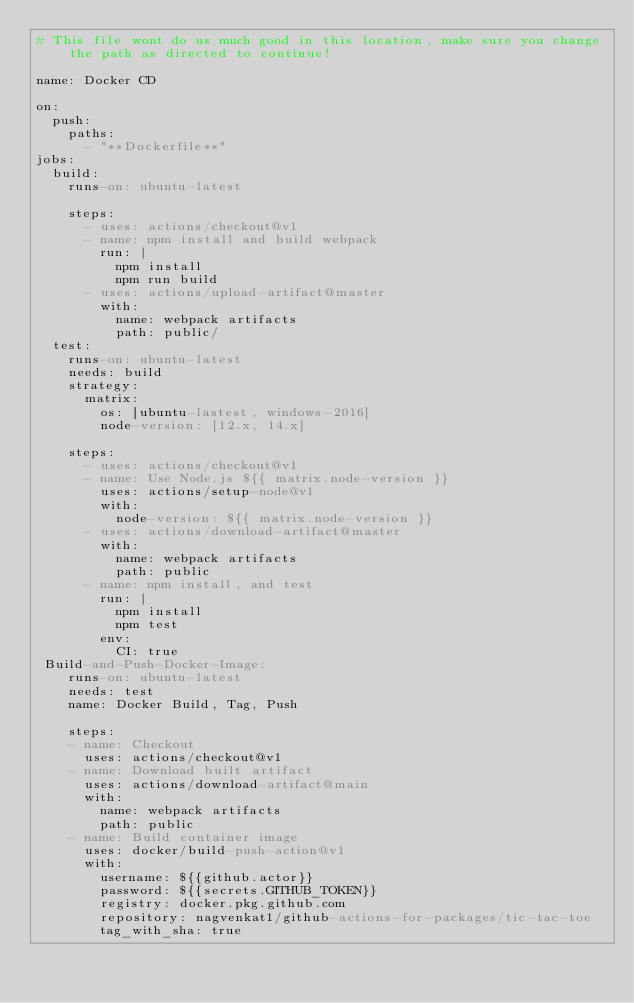Convert code to text. <code><loc_0><loc_0><loc_500><loc_500><_YAML_># This file wont do us much good in this location, make sure you change the path as directed to continue!

name: Docker CD

on:
  push:
    paths:
      - "**Dockerfile**"
jobs:
  build:
    runs-on: ubuntu-latest

    steps:
      - uses: actions/checkout@v1
      - name: npm install and build webpack
        run: |
          npm install
          npm run build
      - uses: actions/upload-artifact@master
        with:
          name: webpack artifacts
          path: public/
  test:
    runs-on: ubuntu-latest
    needs: build
    strategy:
      matrix:
        os: [ubuntu-lastest, windows-2016]
        node-version: [12.x, 14.x]

    steps:
      - uses: actions/checkout@v1
      - name: Use Node.js ${{ matrix.node-version }}
        uses: actions/setup-node@v1
        with:
          node-version: ${{ matrix.node-version }}
      - uses: actions/download-artifact@master
        with:
          name: webpack artifacts
          path: public
      - name: npm install, and test
        run: |
          npm install
          npm test
        env:
          CI: true
 Build-and-Push-Docker-Image:
    runs-on: ubuntu-latest
    needs: test
    name: Docker Build, Tag, Push

    steps:
    - name: Checkout
      uses: actions/checkout@v1
    - name: Download built artifact
      uses: actions/download-artifact@main
      with:
        name: webpack artifacts
        path: public
    - name: Build container image
      uses: docker/build-push-action@v1
      with:
        username: ${{github.actor}}
        password: ${{secrets.GITHUB_TOKEN}}
        registry: docker.pkg.github.com
        repository: nagvenkat1/github-actions-for-packages/tic-tac-toe
        tag_with_sha: true
</code> 